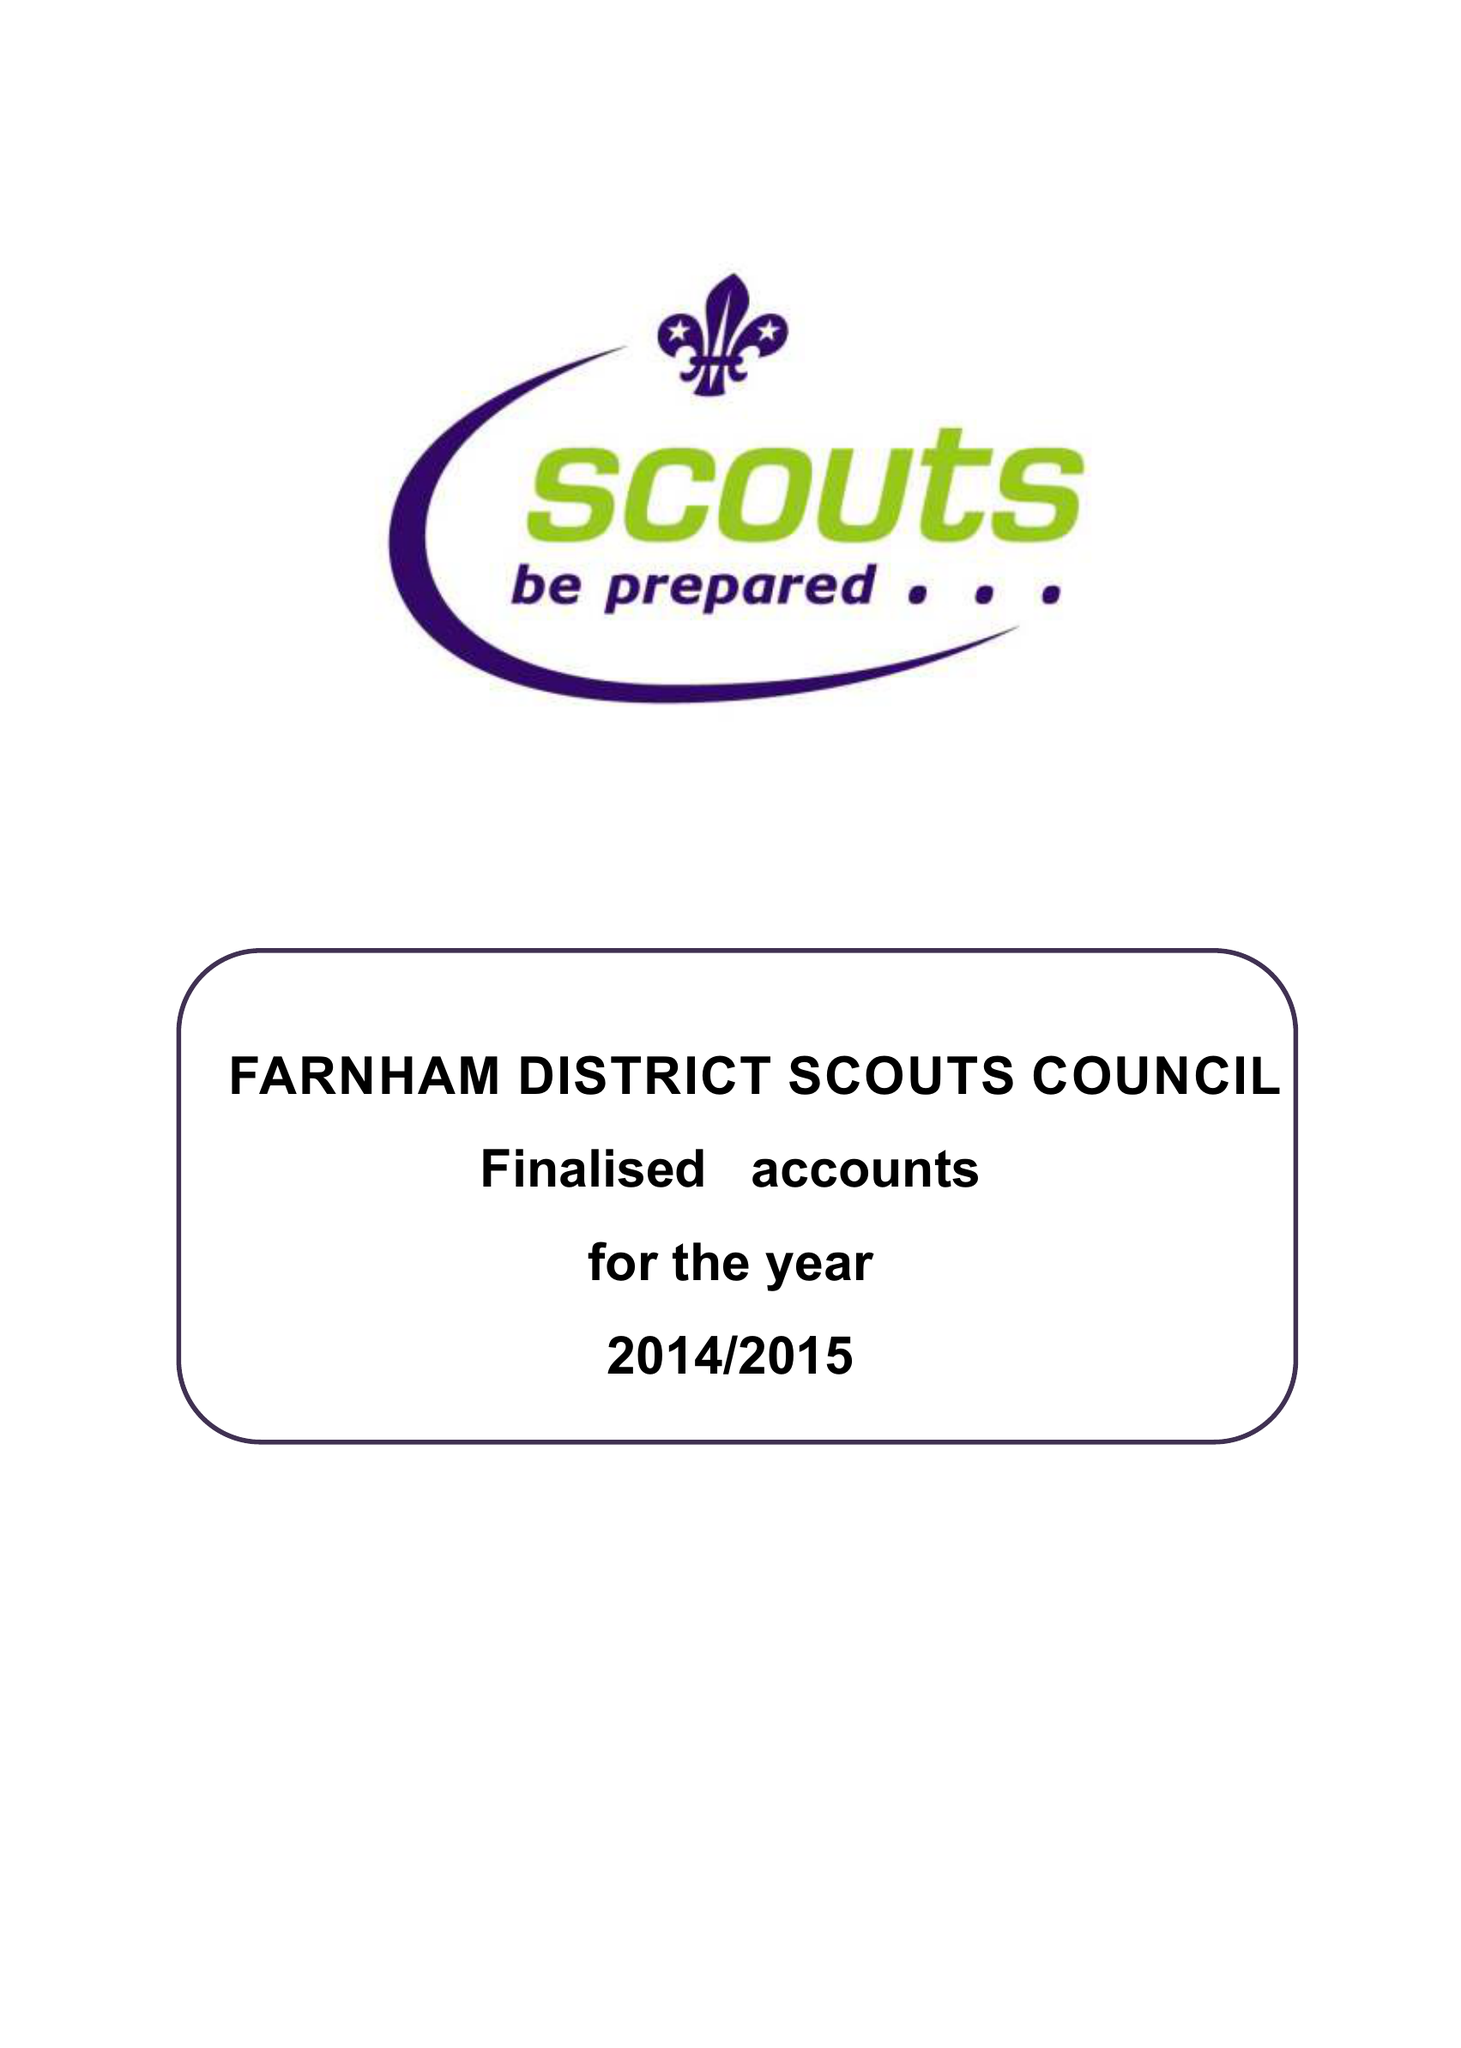What is the value for the report_date?
Answer the question using a single word or phrase. 2015-03-31 